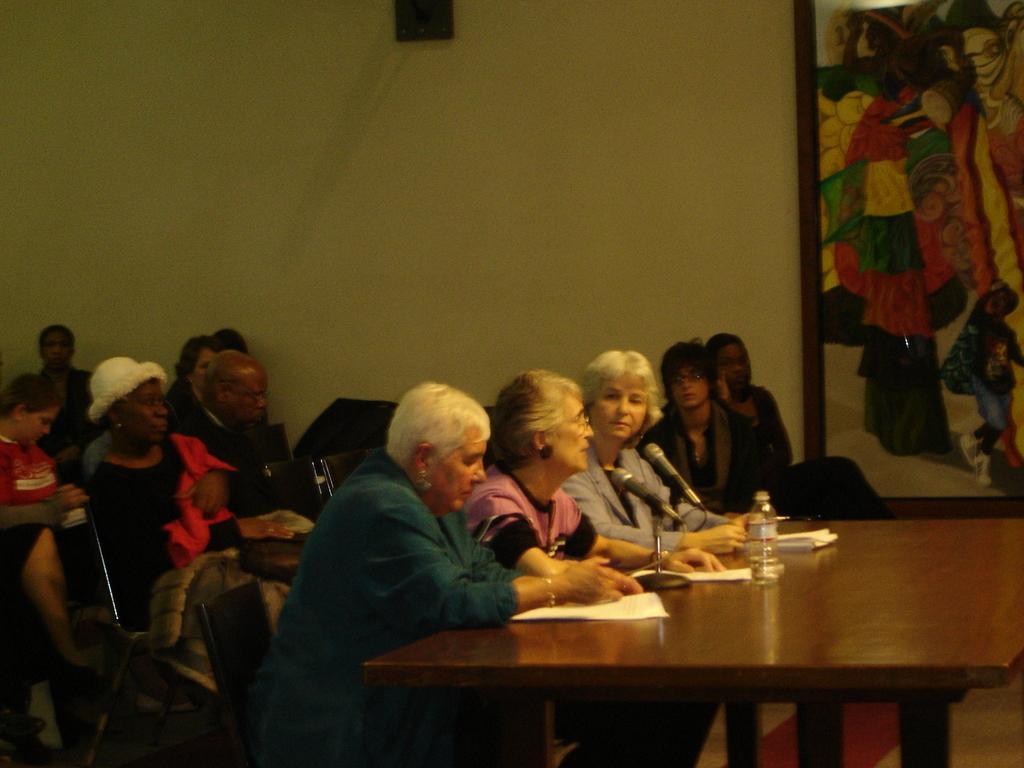Describe this image in one or two sentences. This picture shows people seated on the chairs and we see water bottle,papers on the table and we see a photo frame on the wall 